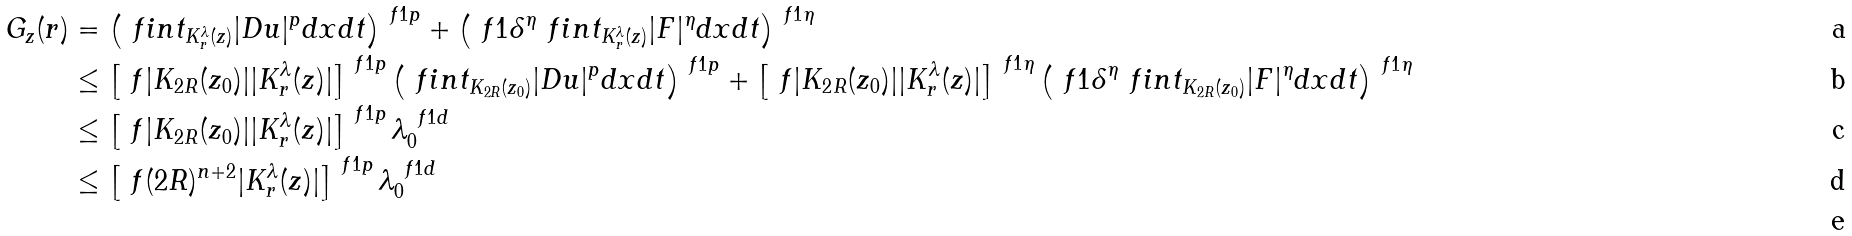<formula> <loc_0><loc_0><loc_500><loc_500>G _ { z } ( r ) & = \left ( \ f i n t _ { K _ { r } ^ { \lambda } ( z ) } | D u | ^ { p } d x d t \right ) ^ { \ f { 1 } { p } } + \left ( \ f { 1 } { \delta ^ { \eta } } \ f i n t _ { K _ { r } ^ { \lambda } ( z ) } | F | ^ { \eta } d x d t \right ) ^ { \ f { 1 } { \eta } } \\ & \leq \left [ \ f { | K _ { 2 R } ( z _ { 0 } ) | } { | K _ { r } ^ { \lambda } ( z ) | } \right ] ^ { \ f { 1 } { p } } \left ( \ f i n t _ { K _ { 2 R } ( z _ { 0 } ) } | D u | ^ { p } d x d t \right ) ^ { \ f { 1 } { p } } + \left [ \ f { | K _ { 2 R } ( z _ { 0 } ) | } { | K _ { r } ^ { \lambda } ( z ) | } \right ] ^ { \ f { 1 } { \eta } } \left ( \ f { 1 } { \delta ^ { \eta } } \ f i n t _ { K _ { 2 R } ( z _ { 0 } ) } | F | ^ { \eta } d x d t \right ) ^ { \ f { 1 } { \eta } } \\ & \leq \left [ \ f { | K _ { 2 R } ( z _ { 0 } ) | } { | K _ { r } ^ { \lambda } ( z ) | } \right ] ^ { \ f { 1 } { p } } \lambda _ { 0 } ^ { \ f { 1 } { d } } \\ & \leq \left [ \ f { ( 2 R ) ^ { n + 2 } } { | K _ { r } ^ { \lambda } ( z ) | } \right ] ^ { \ f { 1 } { p } } \lambda _ { 0 } ^ { \ f { 1 } { d } } \\</formula> 